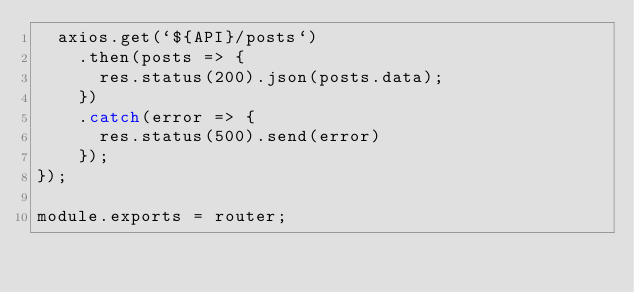<code> <loc_0><loc_0><loc_500><loc_500><_JavaScript_>  axios.get(`${API}/posts`)
    .then(posts => {
      res.status(200).json(posts.data);
    })
    .catch(error => {
      res.status(500).send(error)
    });
});

module.exports = router;</code> 